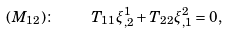<formula> <loc_0><loc_0><loc_500><loc_500>( M _ { 1 2 } ) \colon \quad T _ { 1 1 } \xi ^ { 1 } _ { , 2 } + T _ { 2 2 } \xi ^ { 2 } _ { , 1 } = 0 ,</formula> 